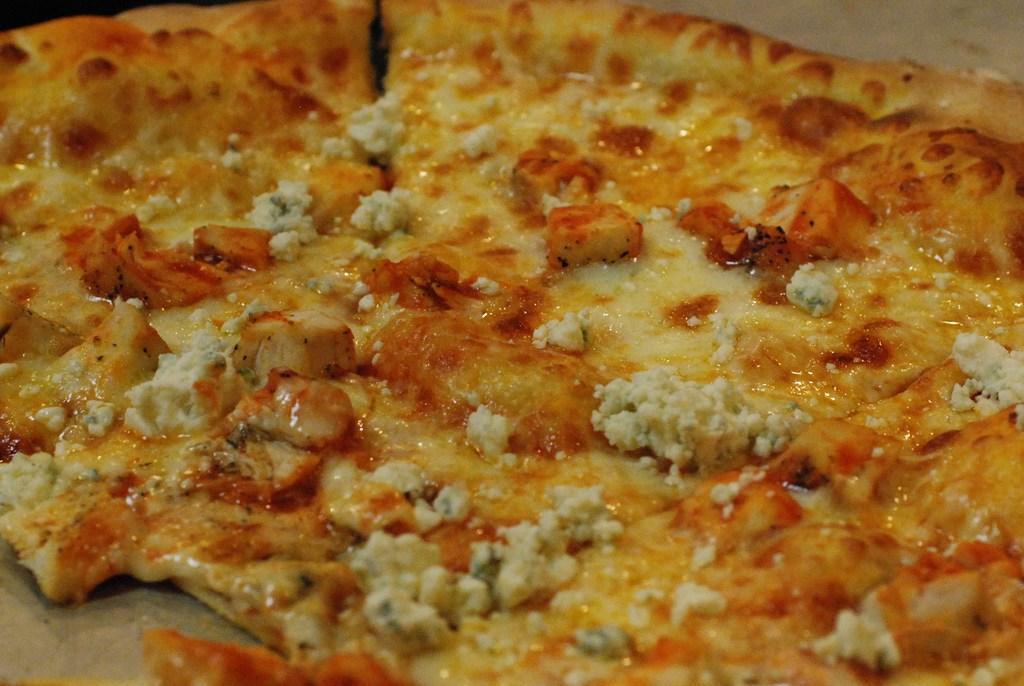Can you describe this image briefly? In this image we can see there is a pizza. 